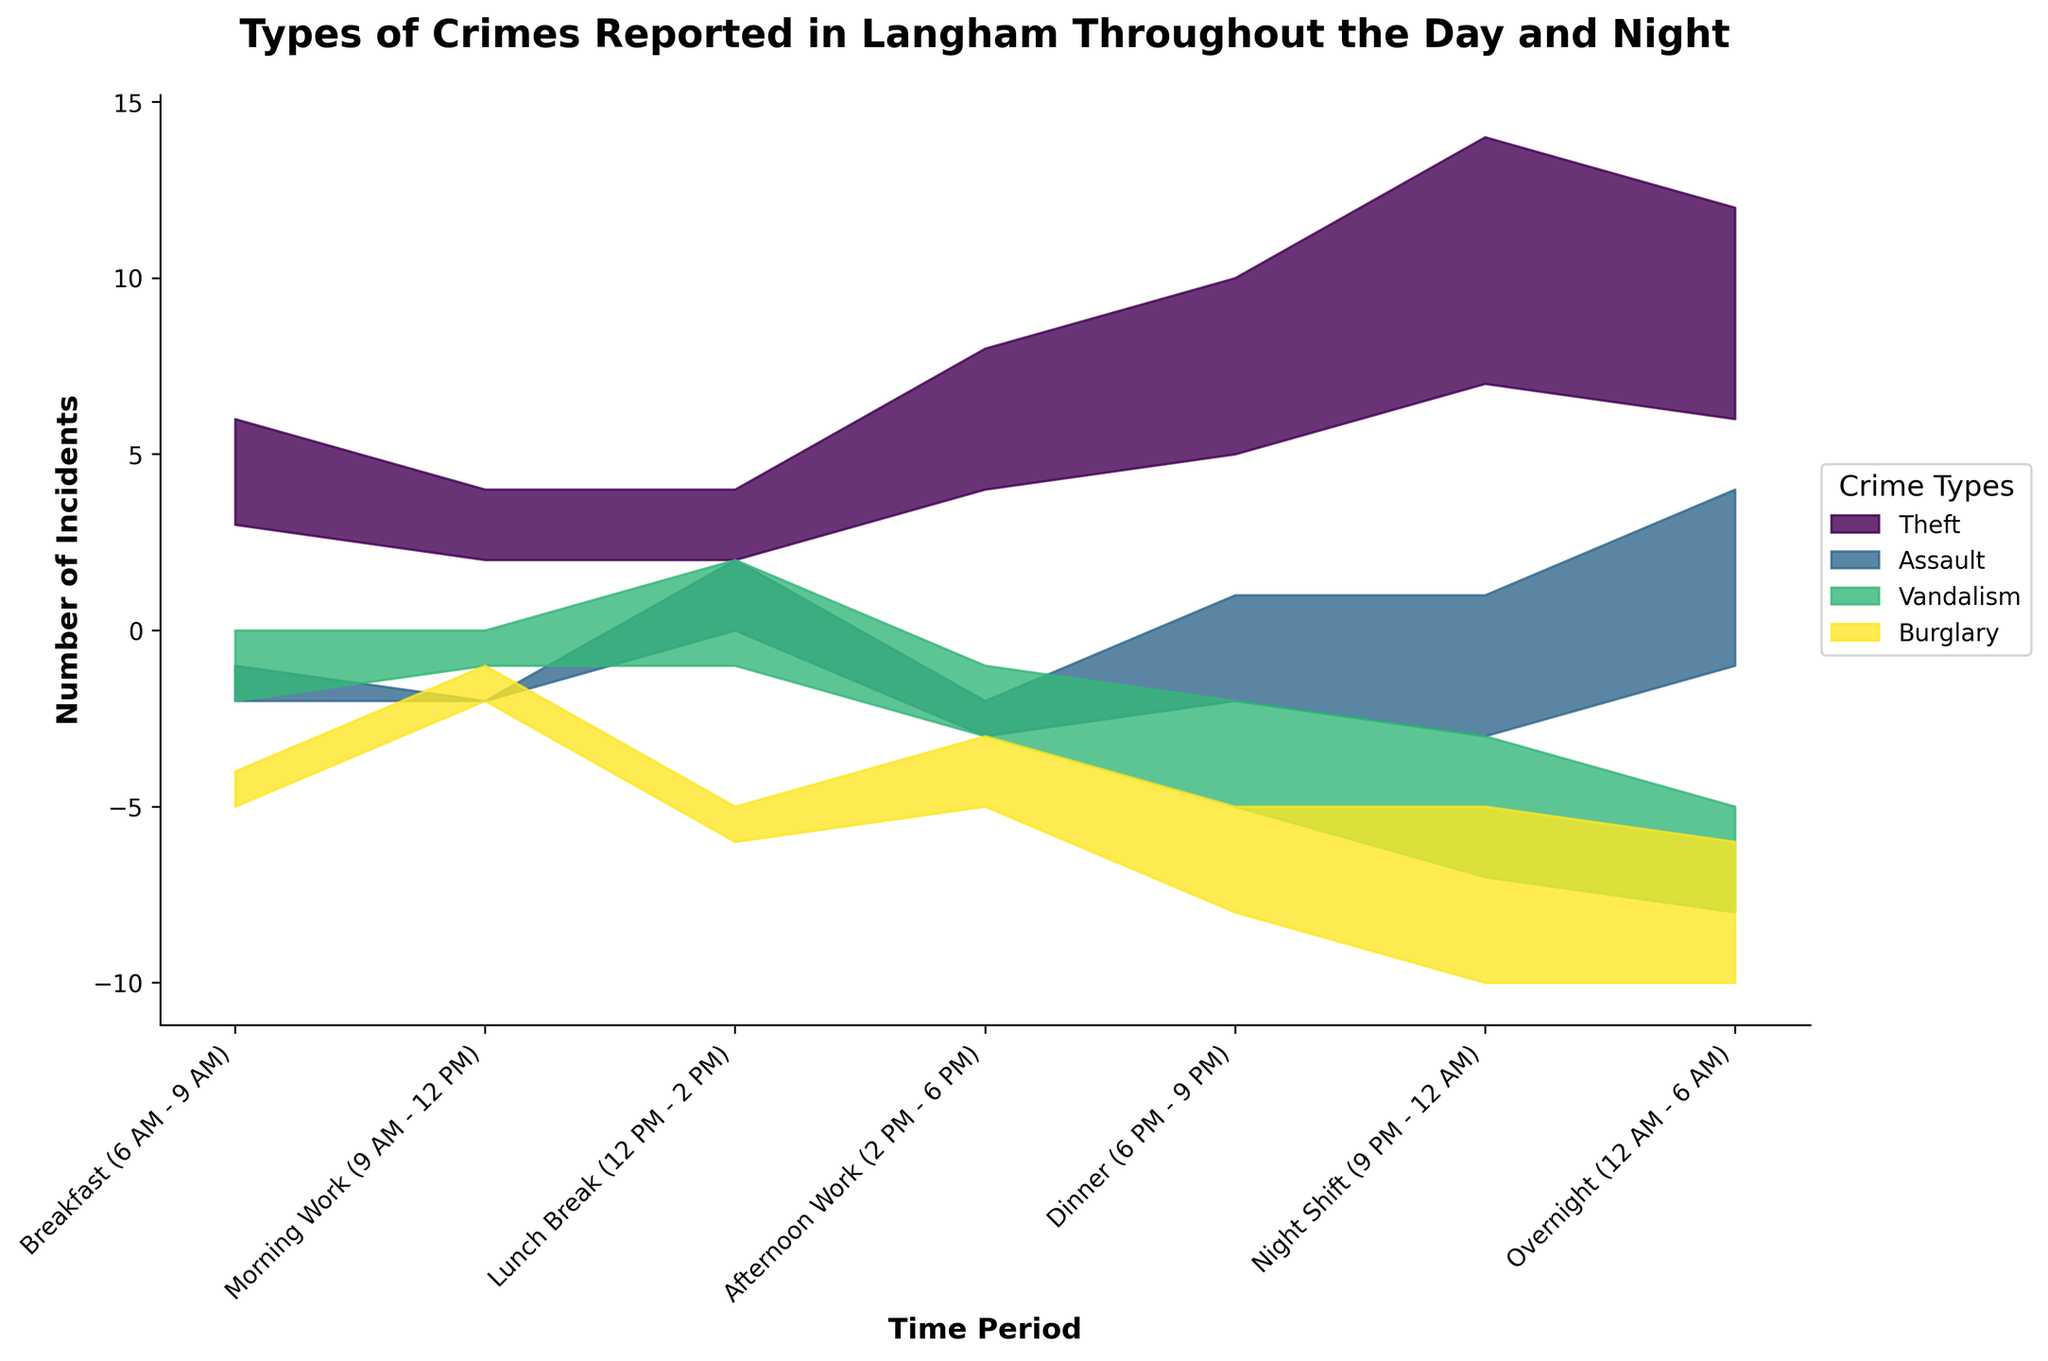Which crime type has the highest number of incidents during the Night Shift (9 PM - 12 AM)? Look at the Night Shift period and identify the highest stream in terms of visual height within this period. The tallest stream corresponds to "Theft".
Answer: Theft During which time period does vandalism peak? Examine the height of the Vandalism stream across all time periods, noting that the peaks occur where the stream is thickest. The peak thickness for Vandalism is during the Lunch Break (12 PM - 2 PM).
Answer: Lunch Break (12 PM - 2 PM) Compare the number of burglary incidents between Dinner (6 PM - 9 PM) and Overnight (12 AM - 6 AM) periods. Which is higher? Compare the height/thickness of the Burglary stream in the Dinner time period with that in the Overnight period. The Burglary stream is thicker during the Overnight period, indicating a higher number of incidents.
Answer: Overnight (12 AM - 6 AM) How many total incidents of assault are reported throughout the Dinner period (6 PM - 9 PM) and the Night Shift period (9 PM - 12 AM)? Add the number of assaults during Dinner and Night Shift periods: 3 (Dinner) + 4 (Night Shift) = 7.
Answer: 7 What is the sum of incidents recorded during Breakfast (6 AM - 9 AM) across all crime types? Add the number of incidents for each crime type during the Breakfast period: Theft (3) + Assault (1) + Vandalism (2) + Burglary (1). The total is 3 + 1 + 2 + 1 = 7.
Answer: 7 Which crime type shows the most consistent or least variation in incidents throughout the day and night? Look for the stream that maintains a relatively even thickness across all time periods. The Assault stream appears the most consistent, as the number of incidents does not vary dramatically compared to others.
Answer: Assault During which time period do the fewest total incidents occur? Sum the incidents for each time period and find the smallest value. Morning Work (9 AM - 12 PM) has the fewest total incidents: Theft (2) + Assault (0) + Vandalism (1) + Burglary (1) = 4.
Answer: Morning Work (9 AM - 12 PM) What is the difference in the number of vandalism incidents between Lunch Break (12 PM - 2 PM) and Overnight (12 AM - 6 AM) periods? Subtract the number of Vandalism incidents in the Overnight period from those in the Lunch Break period: 3 (Lunch Break) - 3 (Overnight) = 0.
Answer: 0 How does the number of theft incidents during Afternoon Work (2 PM - 6 PM) compare to that during Breakfast (6 AM - 9 AM)? Compare the heights of the Theft stream during Breakfast and Afternoon Work periods. There are 4 incidents during Afternoon Work and 3 during Breakfast, so the number is higher in the Afternoon Work period.
Answer: Afternoon Work (2 PM - 6 PM) 